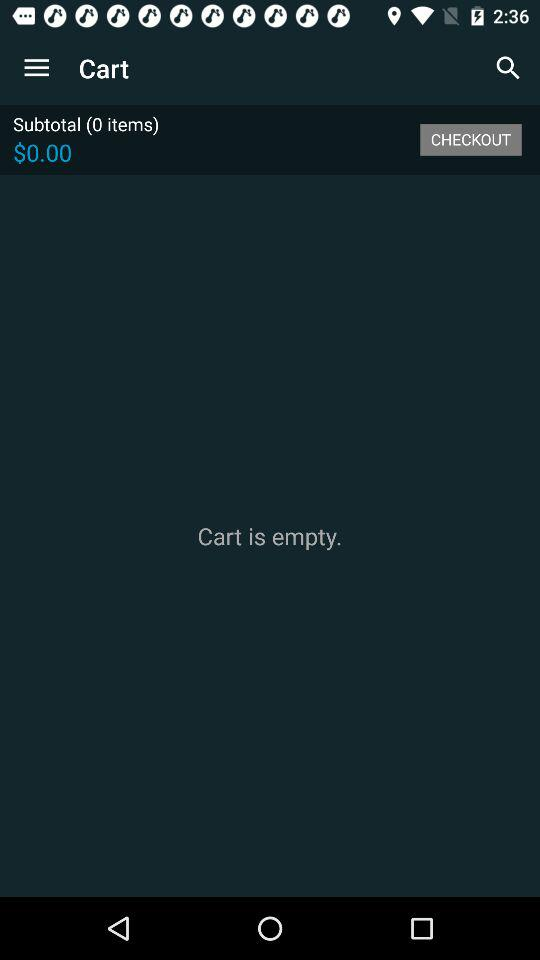What is the total number of items in the cart? The item in the cart is 0. 